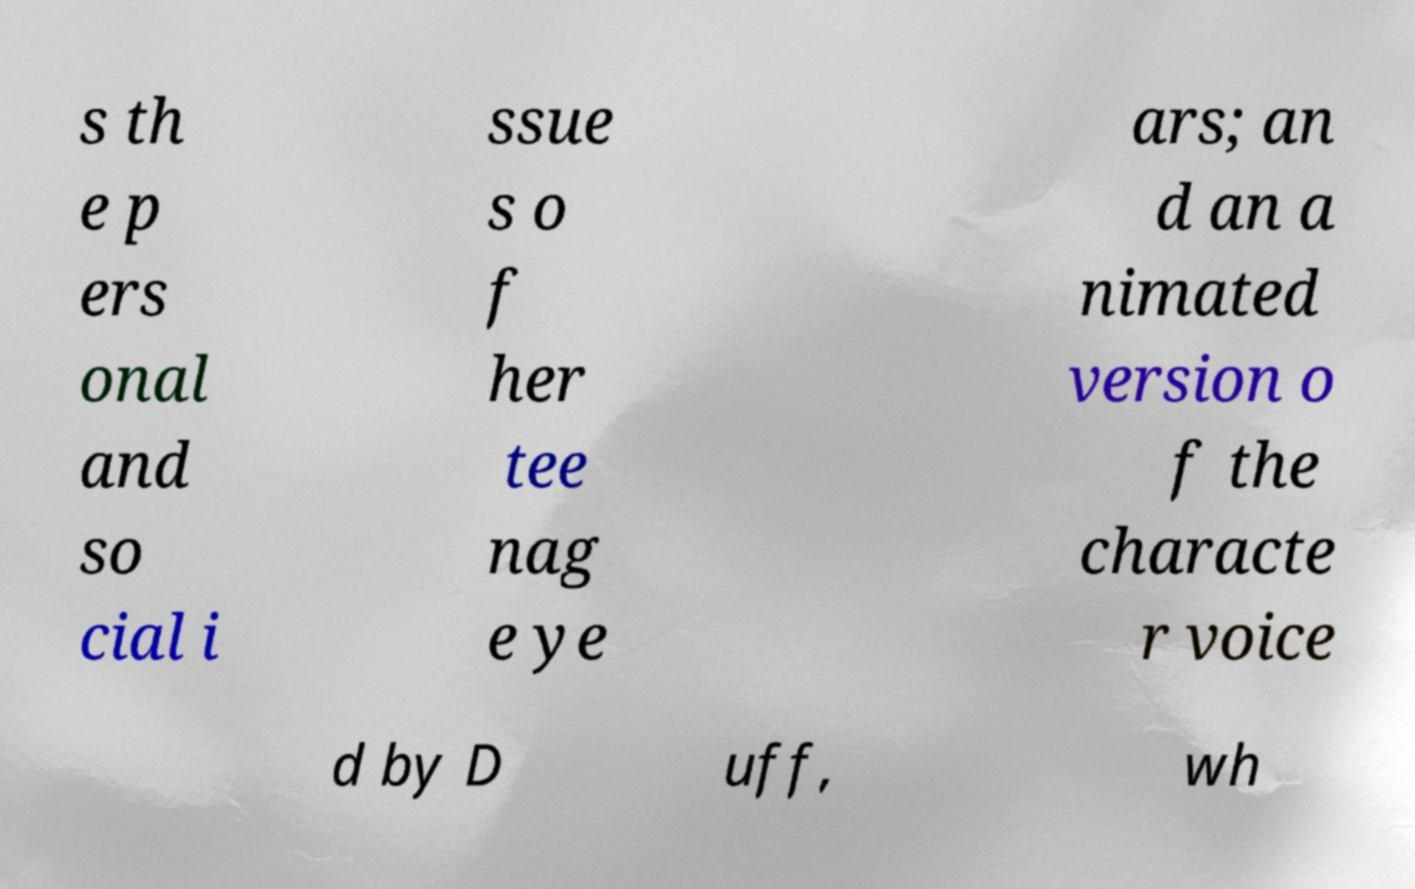For documentation purposes, I need the text within this image transcribed. Could you provide that? s th e p ers onal and so cial i ssue s o f her tee nag e ye ars; an d an a nimated version o f the characte r voice d by D uff, wh 